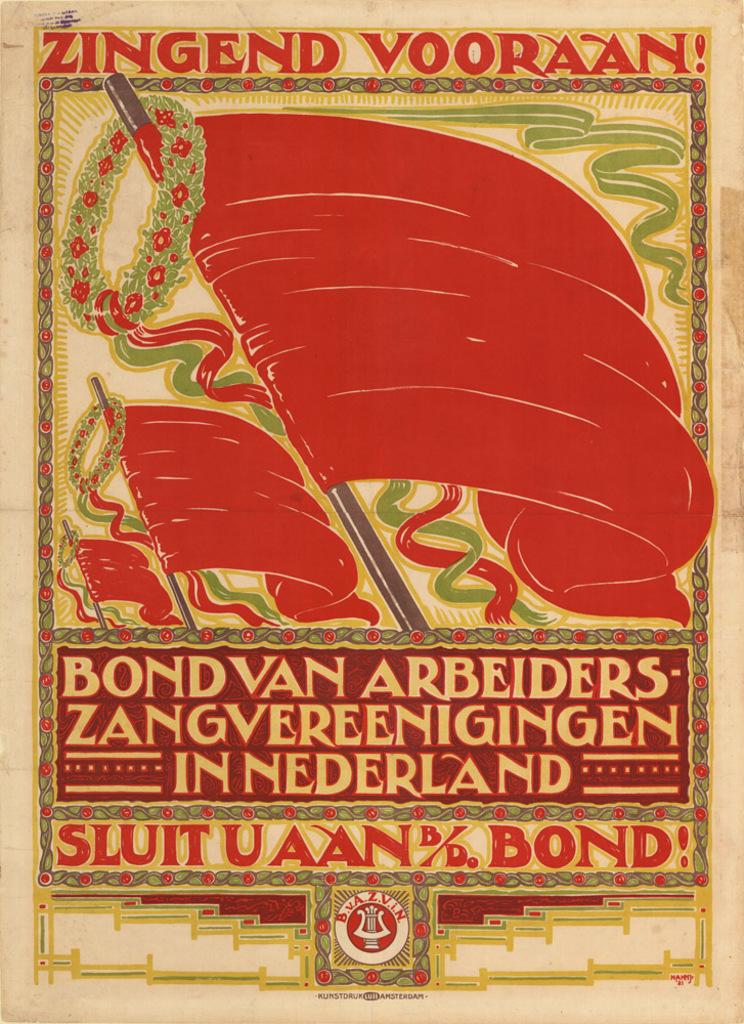What does this ad say?
Offer a terse response. Bondvan arbeiders zangvereenigingen in nederland. 